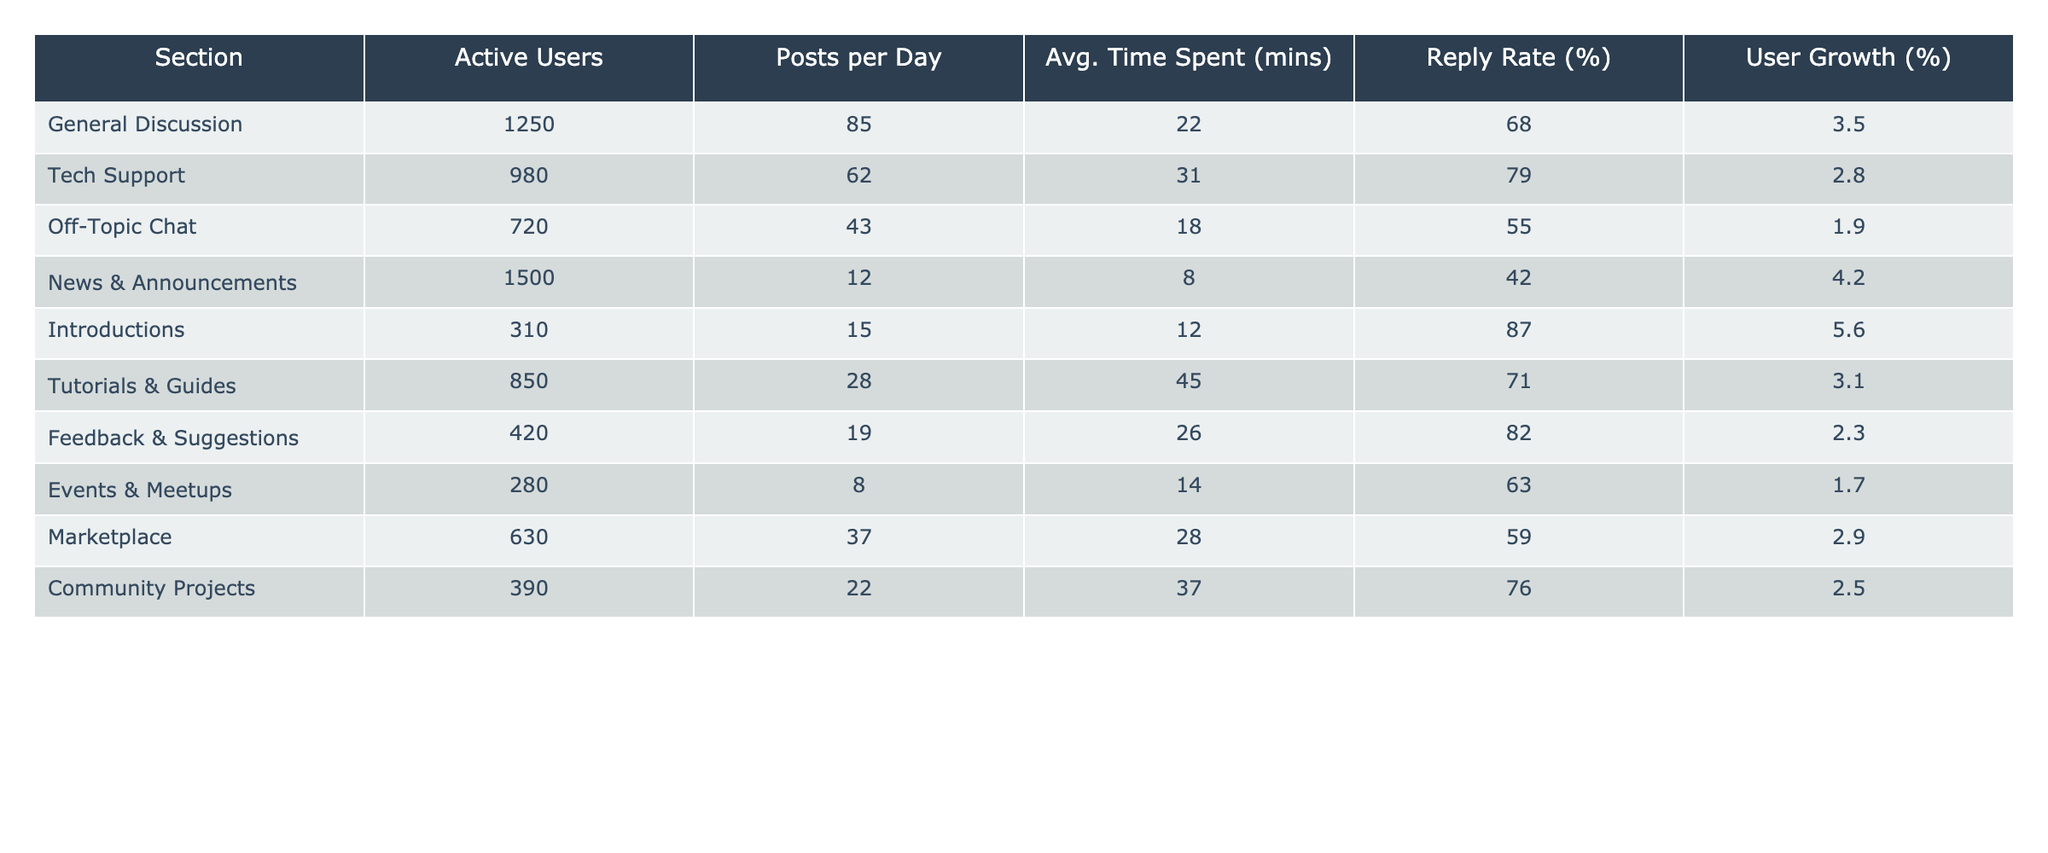What section has the highest number of active users? By reviewing the "Active Users" column, we can see that "News & Announcements" has the highest count at 1500 users.
Answer: News & Announcements Which section has the lowest reply rate? Looking at the "Reply Rate (%)" column, "News & Announcements" has the lowest percentage at 42%.
Answer: News & Announcements What is the average time spent across all sections? We sum the "Avg. Time Spent (mins)" for all sections: (22 + 31 + 18 + 8 + 12 + 45 + 26 + 14 + 28 + 37) =  243 minutes. Then, we divide by the number of sections (10): 243/10 = 24.3.
Answer: 24.3 Is the Tech Support section growing at a higher rate than Off-Topic Chat? The "User Growth (%)" for Tech Support is 2.8% and for Off-Topic Chat it is 1.9%. Since 2.8% is greater than 1.9%, Tech Support is growing at a higher rate.
Answer: Yes What is the cumulative number of posts per day for all sections? We sum the "Posts per Day" for all sections: (85 + 62 + 43 + 12 + 15 + 28 + 19 + 8 + 37 + 22) =  330 posts per day.
Answer: 330 Which sections have an above-average time spent? The average time spent is 24.3 minutes. Sections with above-average time are: Tech Support (31 minutes), Tutorials & Guides (45 minutes).
Answer: Tech Support, Tutorials & Guides Is the Introduction section experiencing user growth? The "User Growth (%)" for Introductions is 5.6%. Since this is greater than 0%, the section is experiencing user growth.
Answer: Yes How many more active users does General Discussion have compared to Events & Meetups? General Discussion has 1250 active users and Events & Meetups has 280. The difference is 1250 - 280 = 970.
Answer: 970 What section has both the highest posts per day and reply rate? The section with the highest posts per day is General Discussion (85 posts) and the highest reply rate is Introductions (87%). Neither section has both the highest metrics together; hence, there is no section that meets both criteria.
Answer: No section meets both criteria 